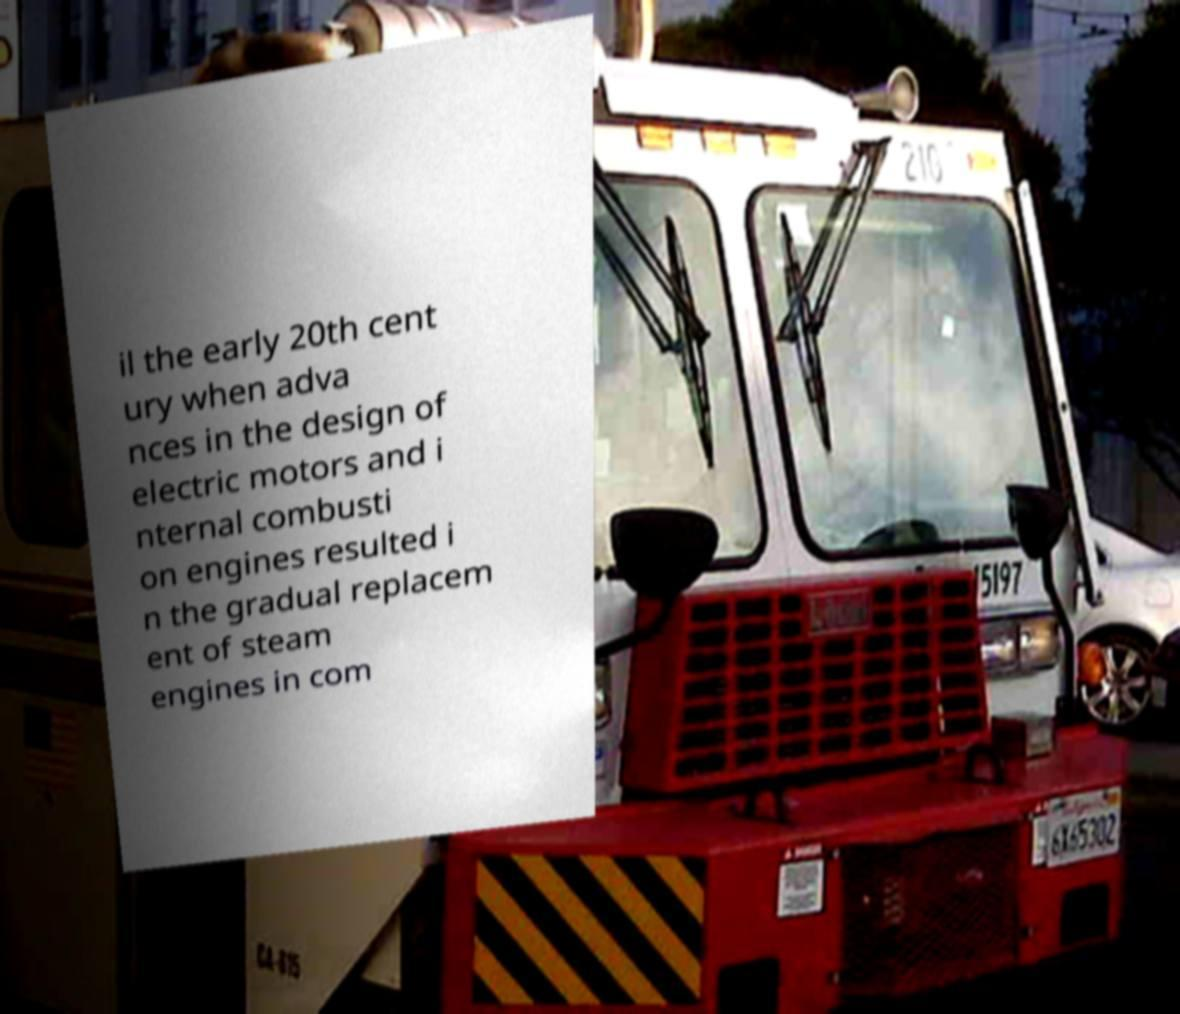Can you accurately transcribe the text from the provided image for me? il the early 20th cent ury when adva nces in the design of electric motors and i nternal combusti on engines resulted i n the gradual replacem ent of steam engines in com 